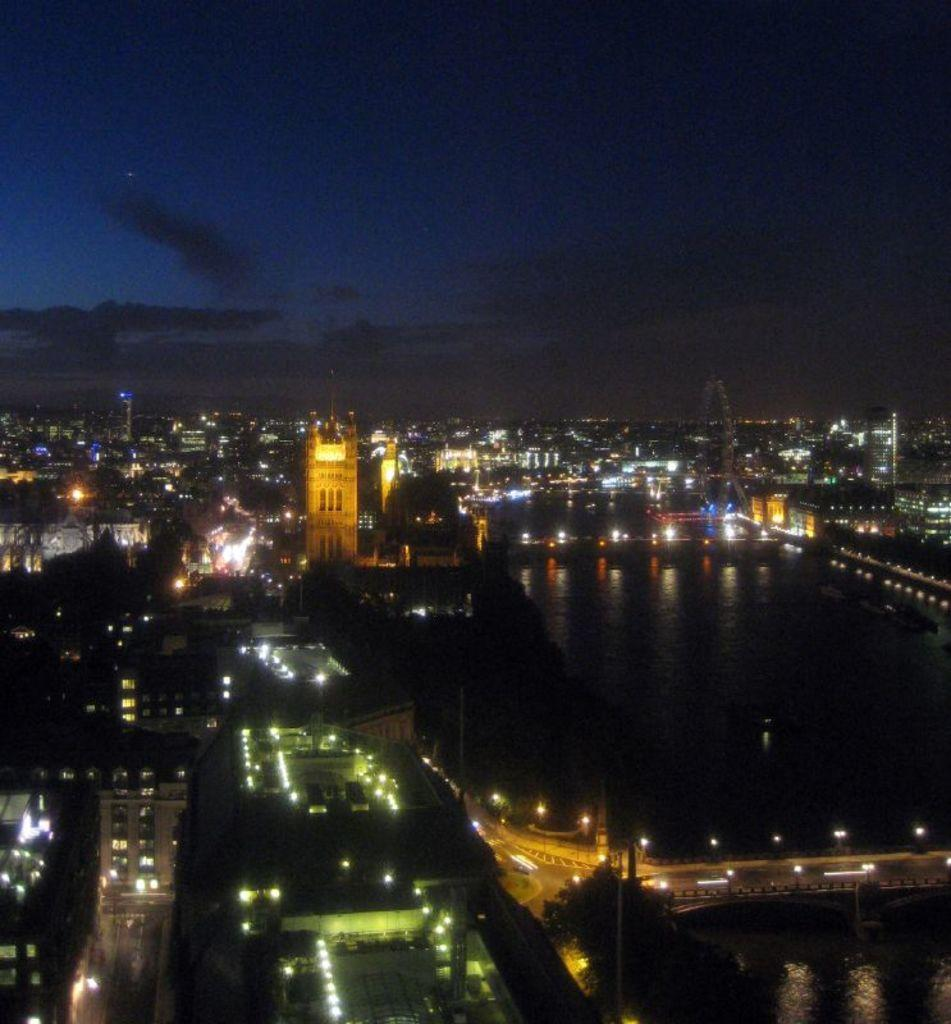What time of day is depicted in the image? The image depicts a night view. What type of structures can be seen in the image? There are group of buildings in the image. What can be observed illuminating the scene in the image? Lights are visible in the image. What is located in the middle of the image? There is water in the middle of the image. What is visible at the top of the image? The sky is visible at the top of the image. What type of ring can be seen on the finger of the person in the image? There is no person present in the image, so it is not possible to determine if there is a ring on their finger. 